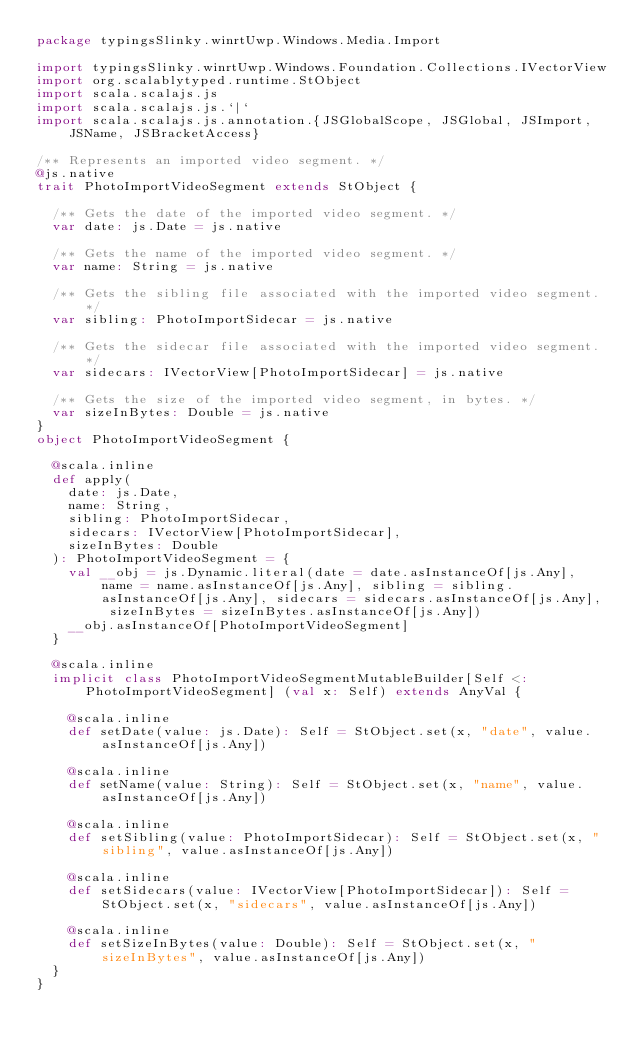Convert code to text. <code><loc_0><loc_0><loc_500><loc_500><_Scala_>package typingsSlinky.winrtUwp.Windows.Media.Import

import typingsSlinky.winrtUwp.Windows.Foundation.Collections.IVectorView
import org.scalablytyped.runtime.StObject
import scala.scalajs.js
import scala.scalajs.js.`|`
import scala.scalajs.js.annotation.{JSGlobalScope, JSGlobal, JSImport, JSName, JSBracketAccess}

/** Represents an imported video segment. */
@js.native
trait PhotoImportVideoSegment extends StObject {
  
  /** Gets the date of the imported video segment. */
  var date: js.Date = js.native
  
  /** Gets the name of the imported video segment. */
  var name: String = js.native
  
  /** Gets the sibling file associated with the imported video segment. */
  var sibling: PhotoImportSidecar = js.native
  
  /** Gets the sidecar file associated with the imported video segment. */
  var sidecars: IVectorView[PhotoImportSidecar] = js.native
  
  /** Gets the size of the imported video segment, in bytes. */
  var sizeInBytes: Double = js.native
}
object PhotoImportVideoSegment {
  
  @scala.inline
  def apply(
    date: js.Date,
    name: String,
    sibling: PhotoImportSidecar,
    sidecars: IVectorView[PhotoImportSidecar],
    sizeInBytes: Double
  ): PhotoImportVideoSegment = {
    val __obj = js.Dynamic.literal(date = date.asInstanceOf[js.Any], name = name.asInstanceOf[js.Any], sibling = sibling.asInstanceOf[js.Any], sidecars = sidecars.asInstanceOf[js.Any], sizeInBytes = sizeInBytes.asInstanceOf[js.Any])
    __obj.asInstanceOf[PhotoImportVideoSegment]
  }
  
  @scala.inline
  implicit class PhotoImportVideoSegmentMutableBuilder[Self <: PhotoImportVideoSegment] (val x: Self) extends AnyVal {
    
    @scala.inline
    def setDate(value: js.Date): Self = StObject.set(x, "date", value.asInstanceOf[js.Any])
    
    @scala.inline
    def setName(value: String): Self = StObject.set(x, "name", value.asInstanceOf[js.Any])
    
    @scala.inline
    def setSibling(value: PhotoImportSidecar): Self = StObject.set(x, "sibling", value.asInstanceOf[js.Any])
    
    @scala.inline
    def setSidecars(value: IVectorView[PhotoImportSidecar]): Self = StObject.set(x, "sidecars", value.asInstanceOf[js.Any])
    
    @scala.inline
    def setSizeInBytes(value: Double): Self = StObject.set(x, "sizeInBytes", value.asInstanceOf[js.Any])
  }
}
</code> 